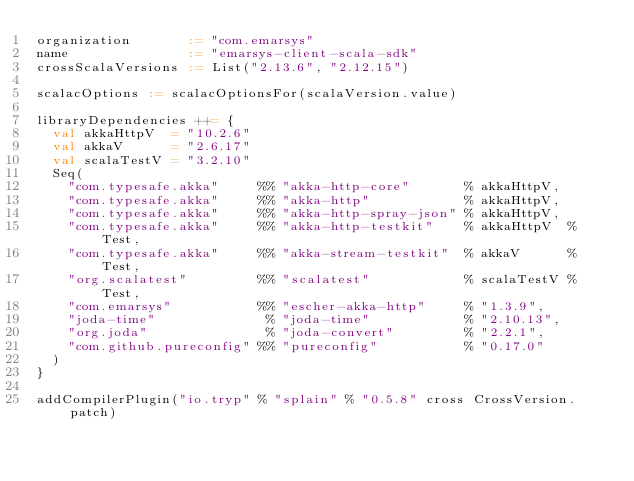<code> <loc_0><loc_0><loc_500><loc_500><_Scala_>organization       := "com.emarsys"
name               := "emarsys-client-scala-sdk"
crossScalaVersions := List("2.13.6", "2.12.15")

scalacOptions := scalacOptionsFor(scalaVersion.value)

libraryDependencies ++= {
  val akkaHttpV  = "10.2.6"
  val akkaV      = "2.6.17"
  val scalaTestV = "3.2.10"
  Seq(
    "com.typesafe.akka"     %% "akka-http-core"       % akkaHttpV,
    "com.typesafe.akka"     %% "akka-http"            % akkaHttpV,
    "com.typesafe.akka"     %% "akka-http-spray-json" % akkaHttpV,
    "com.typesafe.akka"     %% "akka-http-testkit"    % akkaHttpV  % Test,
    "com.typesafe.akka"     %% "akka-stream-testkit"  % akkaV      % Test,
    "org.scalatest"         %% "scalatest"            % scalaTestV % Test,
    "com.emarsys"           %% "escher-akka-http"     % "1.3.9",
    "joda-time"              % "joda-time"            % "2.10.13",
    "org.joda"               % "joda-convert"         % "2.2.1",
    "com.github.pureconfig" %% "pureconfig"           % "0.17.0"
  )
}

addCompilerPlugin("io.tryp" % "splain" % "0.5.8" cross CrossVersion.patch)
</code> 